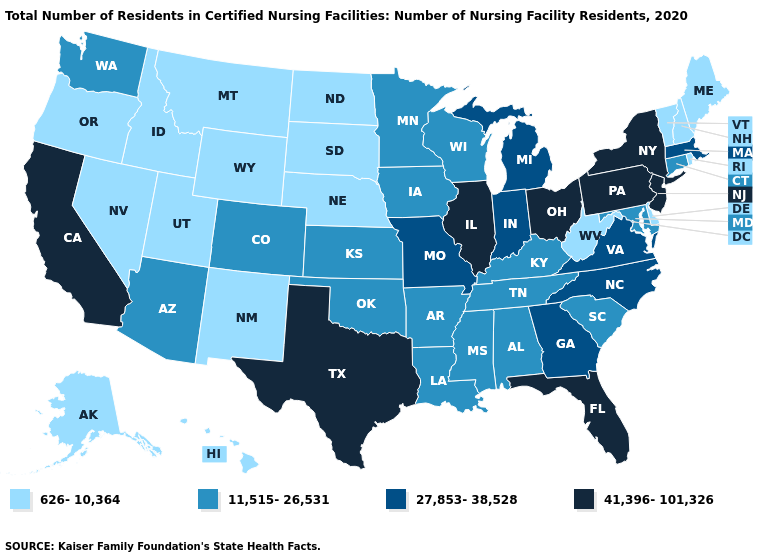What is the value of Wisconsin?
Keep it brief. 11,515-26,531. Among the states that border Tennessee , which have the lowest value?
Be succinct. Alabama, Arkansas, Kentucky, Mississippi. Name the states that have a value in the range 11,515-26,531?
Quick response, please. Alabama, Arizona, Arkansas, Colorado, Connecticut, Iowa, Kansas, Kentucky, Louisiana, Maryland, Minnesota, Mississippi, Oklahoma, South Carolina, Tennessee, Washington, Wisconsin. Does the first symbol in the legend represent the smallest category?
Give a very brief answer. Yes. Name the states that have a value in the range 27,853-38,528?
Give a very brief answer. Georgia, Indiana, Massachusetts, Michigan, Missouri, North Carolina, Virginia. Does New York have the highest value in the USA?
Be succinct. Yes. Among the states that border Georgia , does Alabama have the highest value?
Give a very brief answer. No. Does Idaho have the highest value in the West?
Give a very brief answer. No. Does Illinois have the highest value in the MidWest?
Short answer required. Yes. Name the states that have a value in the range 626-10,364?
Write a very short answer. Alaska, Delaware, Hawaii, Idaho, Maine, Montana, Nebraska, Nevada, New Hampshire, New Mexico, North Dakota, Oregon, Rhode Island, South Dakota, Utah, Vermont, West Virginia, Wyoming. What is the value of Washington?
Give a very brief answer. 11,515-26,531. Which states have the highest value in the USA?
Keep it brief. California, Florida, Illinois, New Jersey, New York, Ohio, Pennsylvania, Texas. Which states have the lowest value in the USA?
Short answer required. Alaska, Delaware, Hawaii, Idaho, Maine, Montana, Nebraska, Nevada, New Hampshire, New Mexico, North Dakota, Oregon, Rhode Island, South Dakota, Utah, Vermont, West Virginia, Wyoming. Among the states that border Ohio , does West Virginia have the lowest value?
Write a very short answer. Yes. Name the states that have a value in the range 27,853-38,528?
Give a very brief answer. Georgia, Indiana, Massachusetts, Michigan, Missouri, North Carolina, Virginia. 